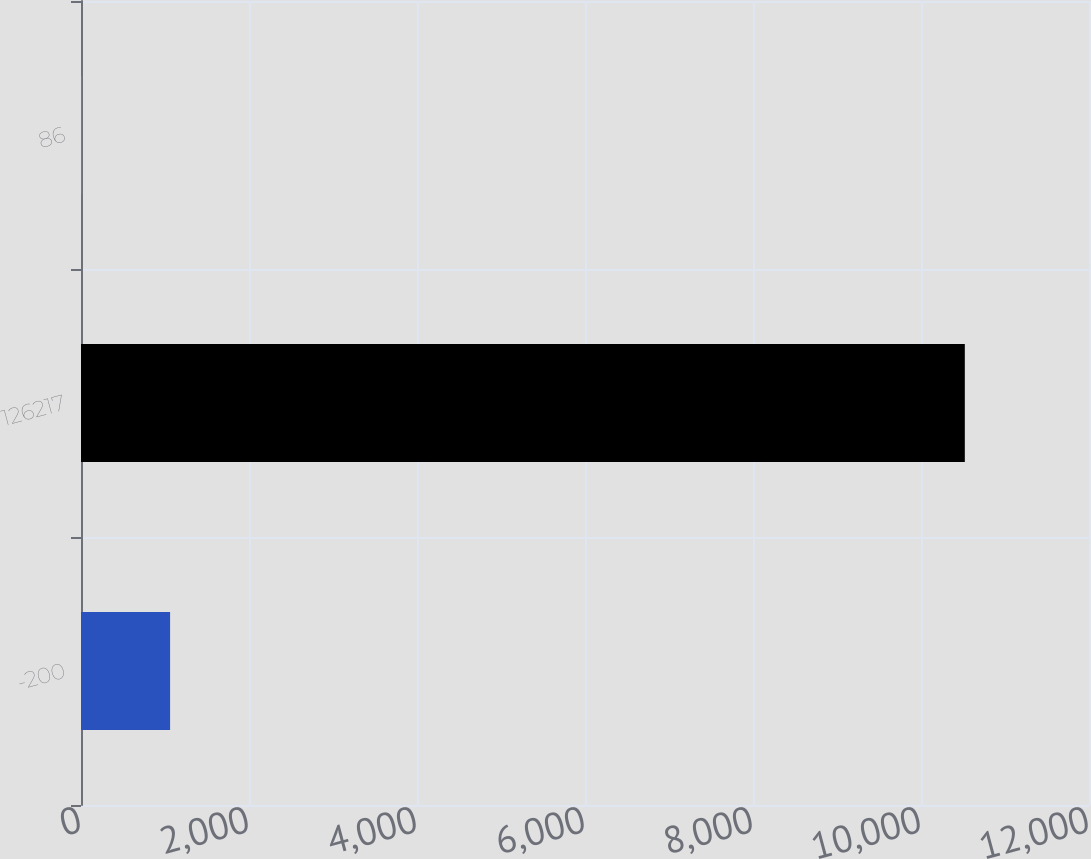Convert chart to OTSL. <chart><loc_0><loc_0><loc_500><loc_500><bar_chart><fcel>-200<fcel>126217<fcel>86<nl><fcel>1060.72<fcel>10521.7<fcel>9.5<nl></chart> 